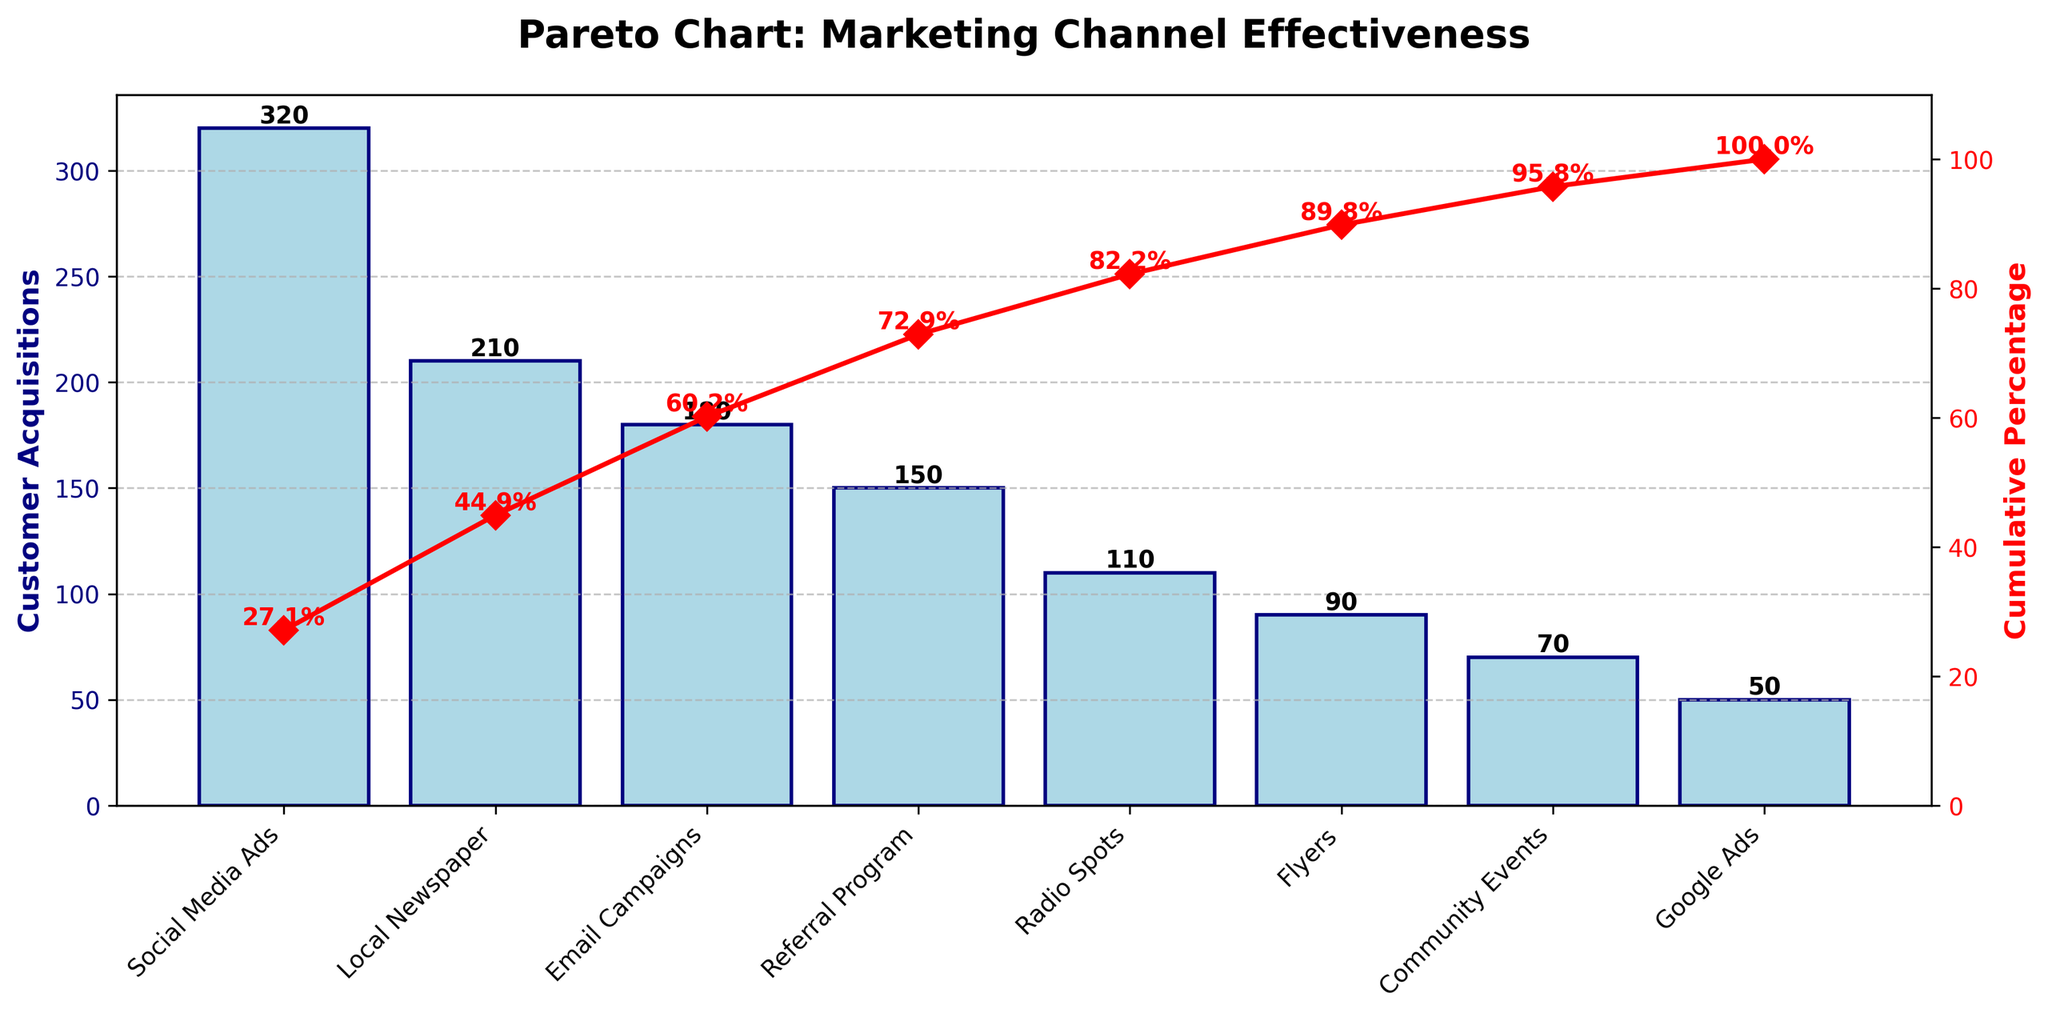what is the title of the figure? The title of the figure can be identified at the top center of the chart. It states "Pareto Chart: Marketing Channel Effectiveness".
Answer: Pareto Chart: Marketing Channel Effectiveness Which marketing channel has the highest customer acquisitions? By examining the heights of the bars in the chart, the tallest bar corresponds to "Social Media Ads" with the highest customer acquisitions at 320.
Answer: Social Media Ads What is the total number of customer acquisitions? To find the total, sum up all the values of customer acquisitions from each channel: 320 + 210 + 180 + 150 + 110 + 90 + 70 + 50 = 1180.
Answer: 1180 How many marketing channels are shown in the figure? By counting the number of bars (one for each marketing channel) in the chart, there are 8 marketing channels listed.
Answer: 8 Which marketing channel shows the lowest customer acquisitions? The shortest bar in the chart indicates the marketing channel with the lowest customer acquisitions. "Google Ads" has the shortest bar at 50 customer acquisitions.
Answer: Google Ads What is the cumulative percentage after the top three marketing channels? To find this, look at the cumulative percentage line after the first three bars: Social Media Ads, Local Newspaper, and Email Campaigns. The chart shows approximately 59.3% cumulative percentage at this point.
Answer: 59.3% What are the customer acquisitions for Email Campaigns and Community Events combined? Refer to the bars for "Email Campaigns" and "Community Events" and sum their values: 180 (Email Campaigns) + 70 (Community Events) = 250.
Answer: 250 Which channels contribute to at least 80% of the cumulative customer acquisitions? Look at the point where the cumulative percentage line crosses the 80% mark and identify the corresponding channels: Social Media Ads, Local Newspaper, Email Campaigns, and Referral Program.
Answer: Social Media Ads, Local Newspaper, Email Campaigns, Referral Program How does the customer acquisition for Local Newspaper compare to Radio Spots? Compare the height of the bars for "Local Newspaper" (210) and "Radio Spots" (110). Local Newspaper has higher customer acquisitions than Radio Spots.
Answer: Local Newspaper has more What is the cumulative percentage at the point where Flyers are included? Find the Flyers channel on the x-axis and refer to the cumulative percentage marker at that bar, which is approximately 91.5%.
Answer: 91.5% 